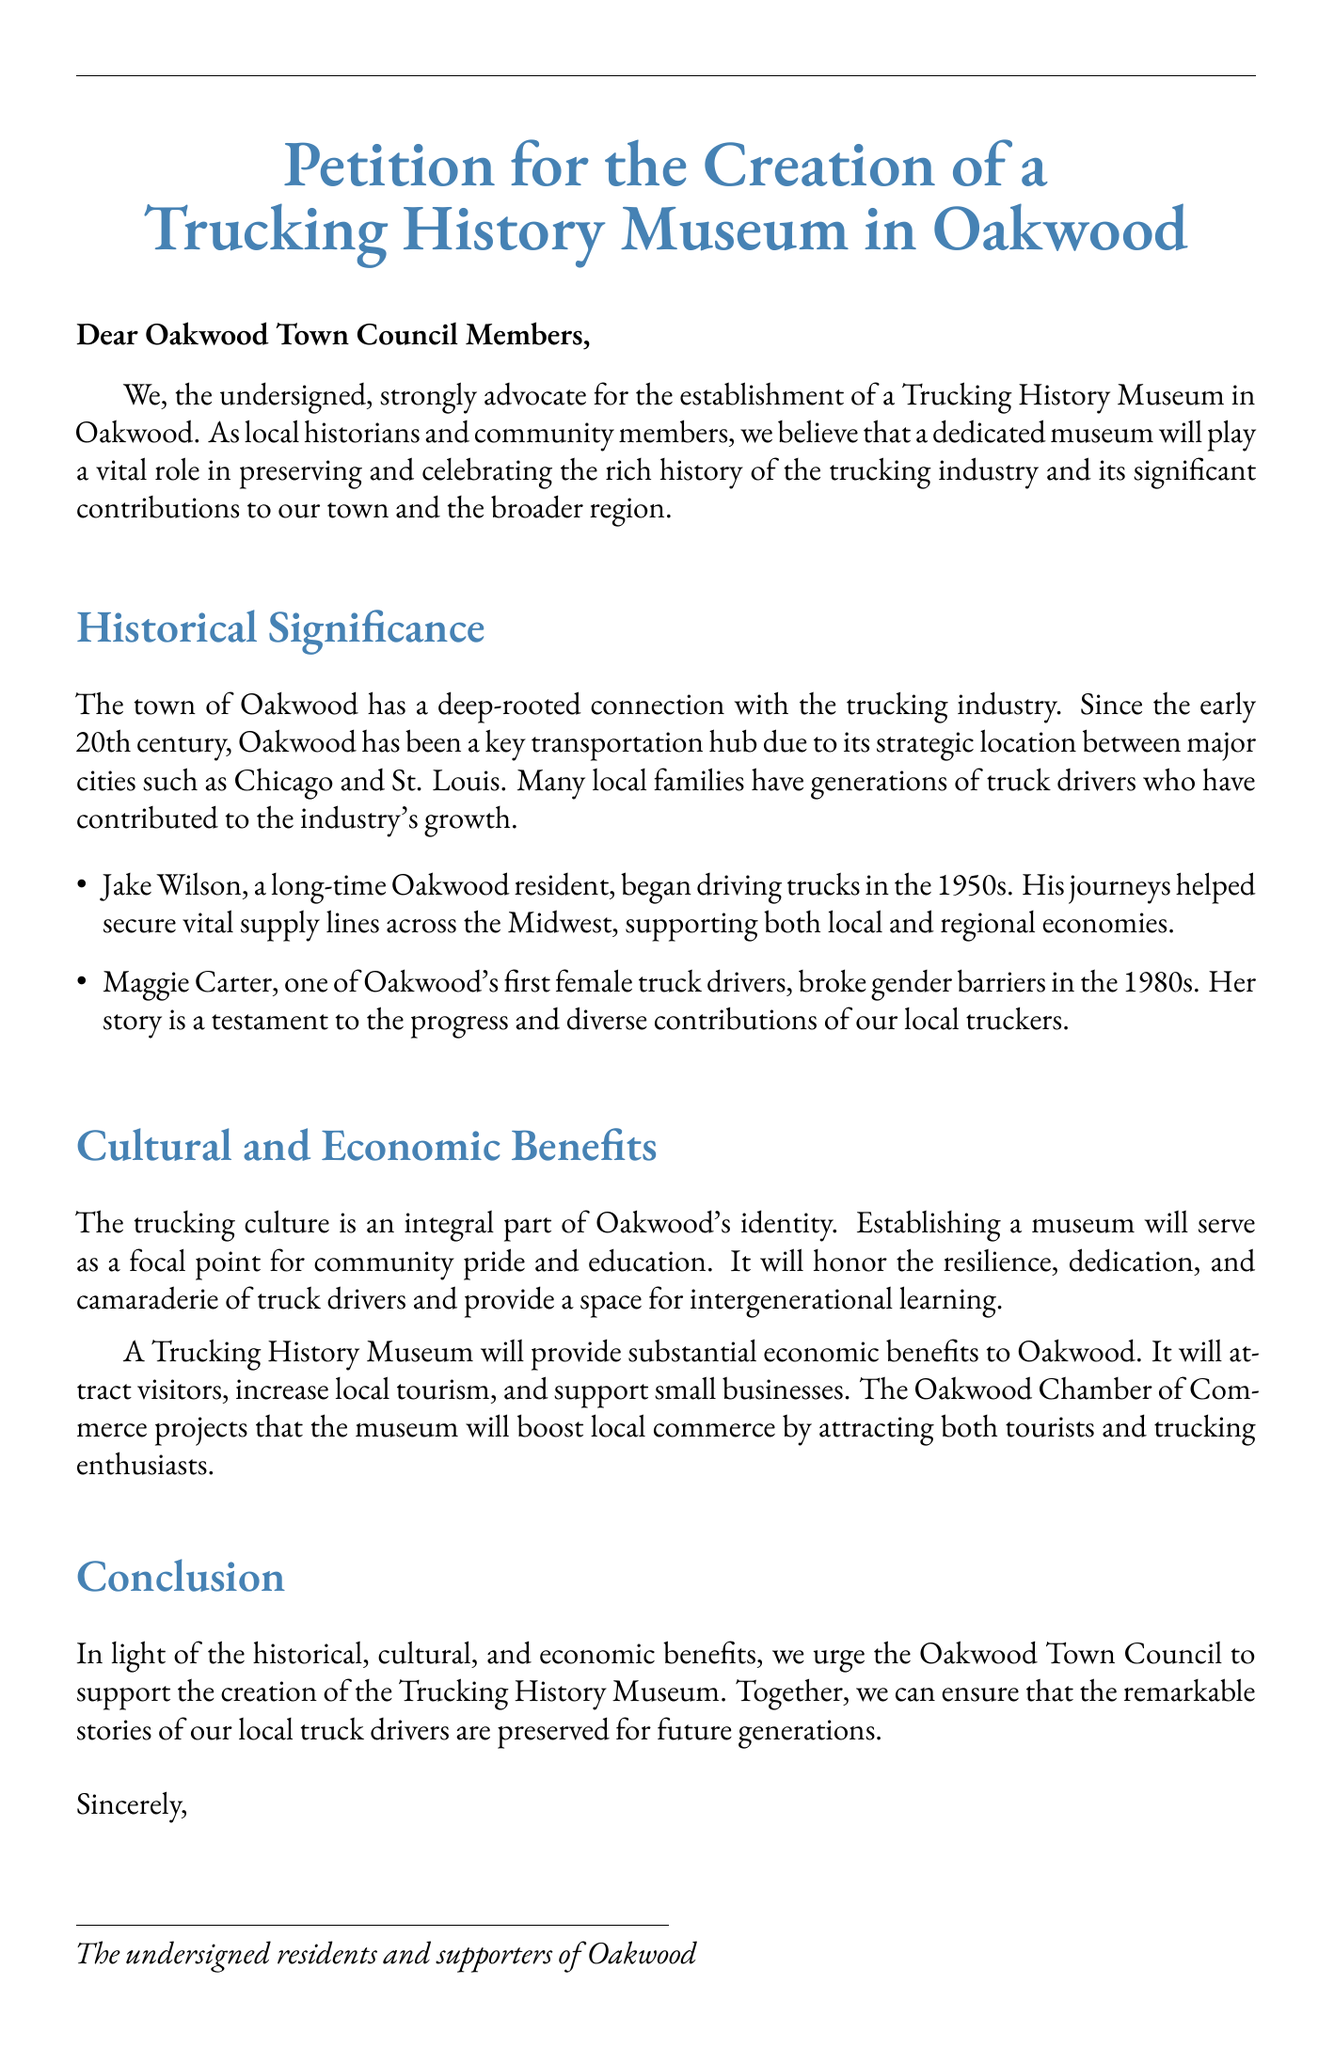What is the title of the petition? The title of the petition is the main heading displayed prominently at the top, summarizing its purpose.
Answer: Petition for the Creation of a Trucking History Museum in Oakwood Who is the petition addressed to? The petition addresses specific members of a governing body, indicating the intended audience for the request.
Answer: Oakwood Town Council Members In what decade did Jake Wilson begin driving trucks? Jake Wilson’s start in the trucking industry is highlighted as part of the historical context provided in the document.
Answer: 1950s What barrier did Maggie Carter break in the 1980s? The document notes a significant achievement by Maggie Carter, focusing on societal changes related to gender roles in the industry.
Answer: Gender barriers What is one economic benefit of the Trucking History Museum? The document outlines positive impacts on the local economy, emphasizing practical benefits for the community.
Answer: Attract tourists How does the petition describe the significance of Oakwood's location? The significance is linked to the historical context, explaining Oakwood's role in transportation between major cities.
Answer: Key transportation hub What type of document is this? This refers to the nature of the content, defining what the document represents and aims to achieve.
Answer: Petition How does the petition aim to serve future generations? This is aimed at understanding the long-term goals of the museum as presented in the conclusion of the document.
Answer: Preserve stories What project does the Oakwood Chamber of Commerce support? The document mentions a project that aligns with community aspirations and ideas for local improvement.
Answer: Trucking History Museum 